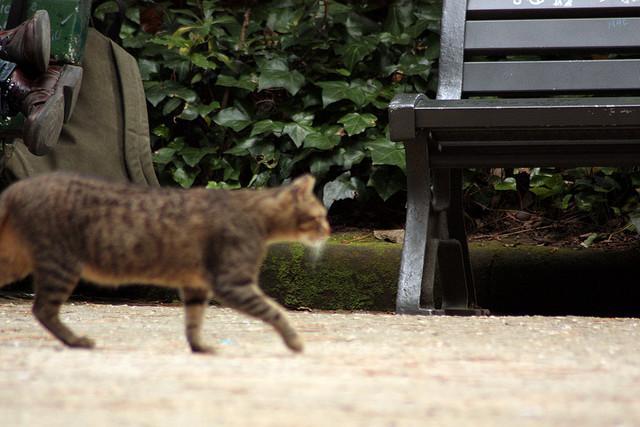Where is the cat standing?
Answer briefly. Ground. Do you see human feet?
Keep it brief. Yes. Do you see a park bench?
Concise answer only. Yes. Is the cat looking for a mouse?
Give a very brief answer. No. 